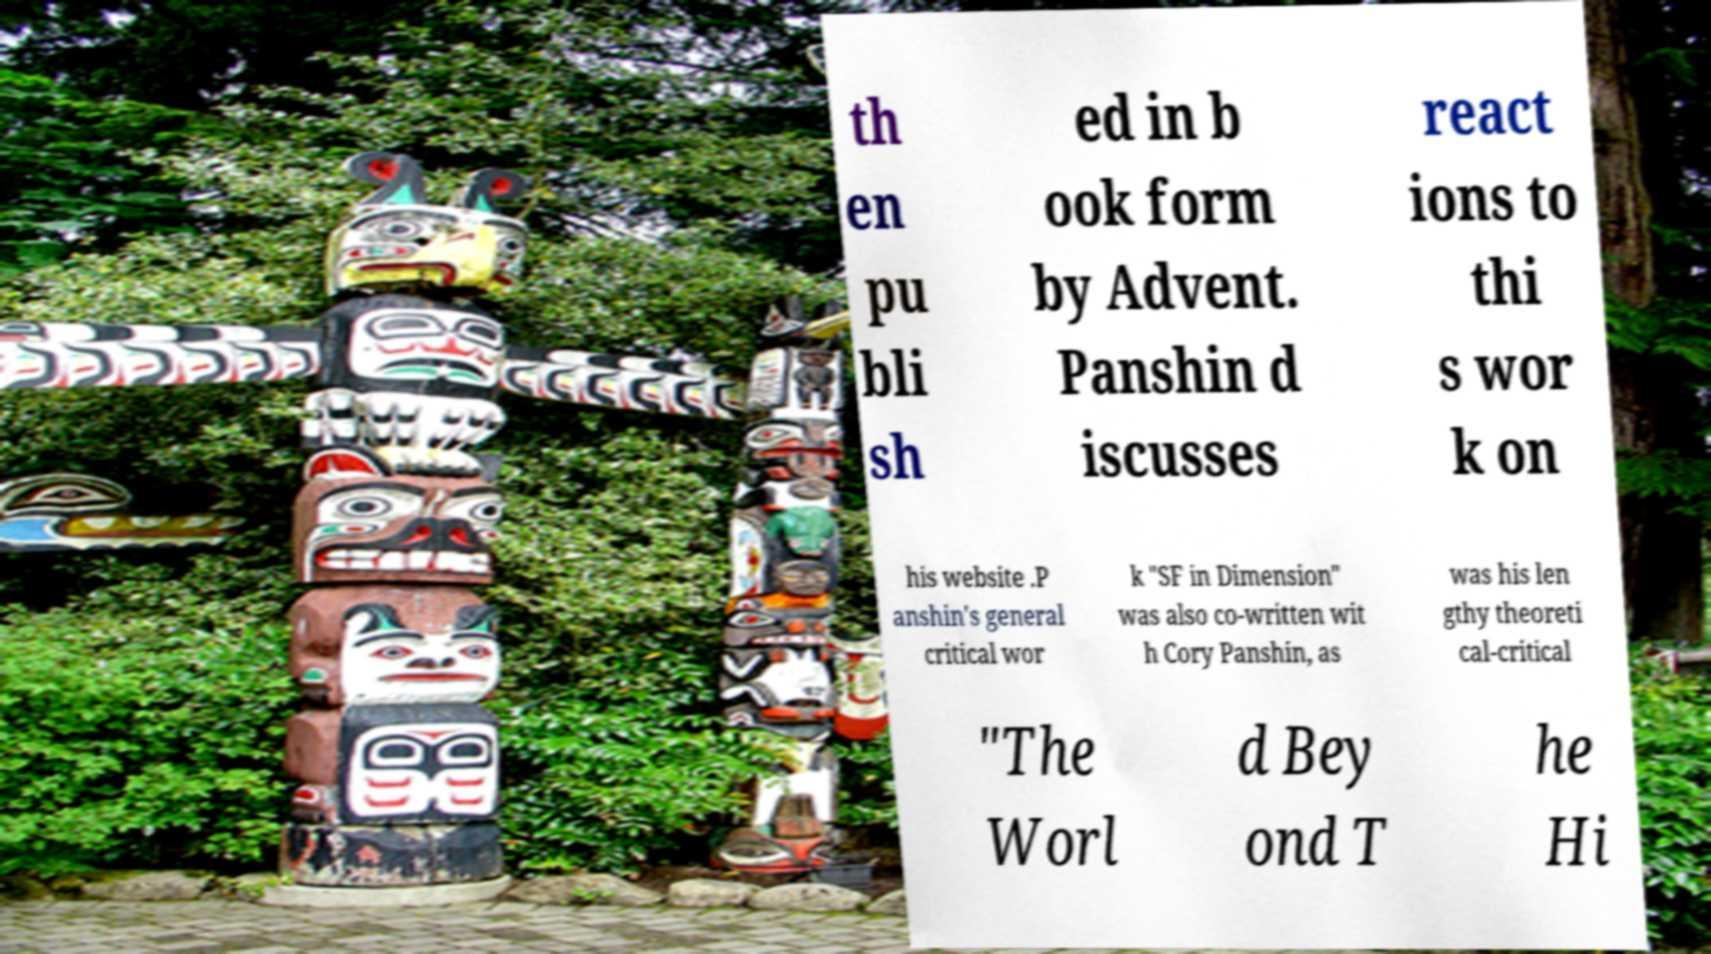Can you accurately transcribe the text from the provided image for me? th en pu bli sh ed in b ook form by Advent. Panshin d iscusses react ions to thi s wor k on his website .P anshin's general critical wor k "SF in Dimension" was also co-written wit h Cory Panshin, as was his len gthy theoreti cal-critical "The Worl d Bey ond T he Hi 